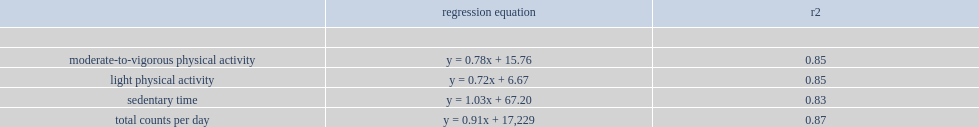What is the minimum and maximum of r2? 0.83 0.87. 